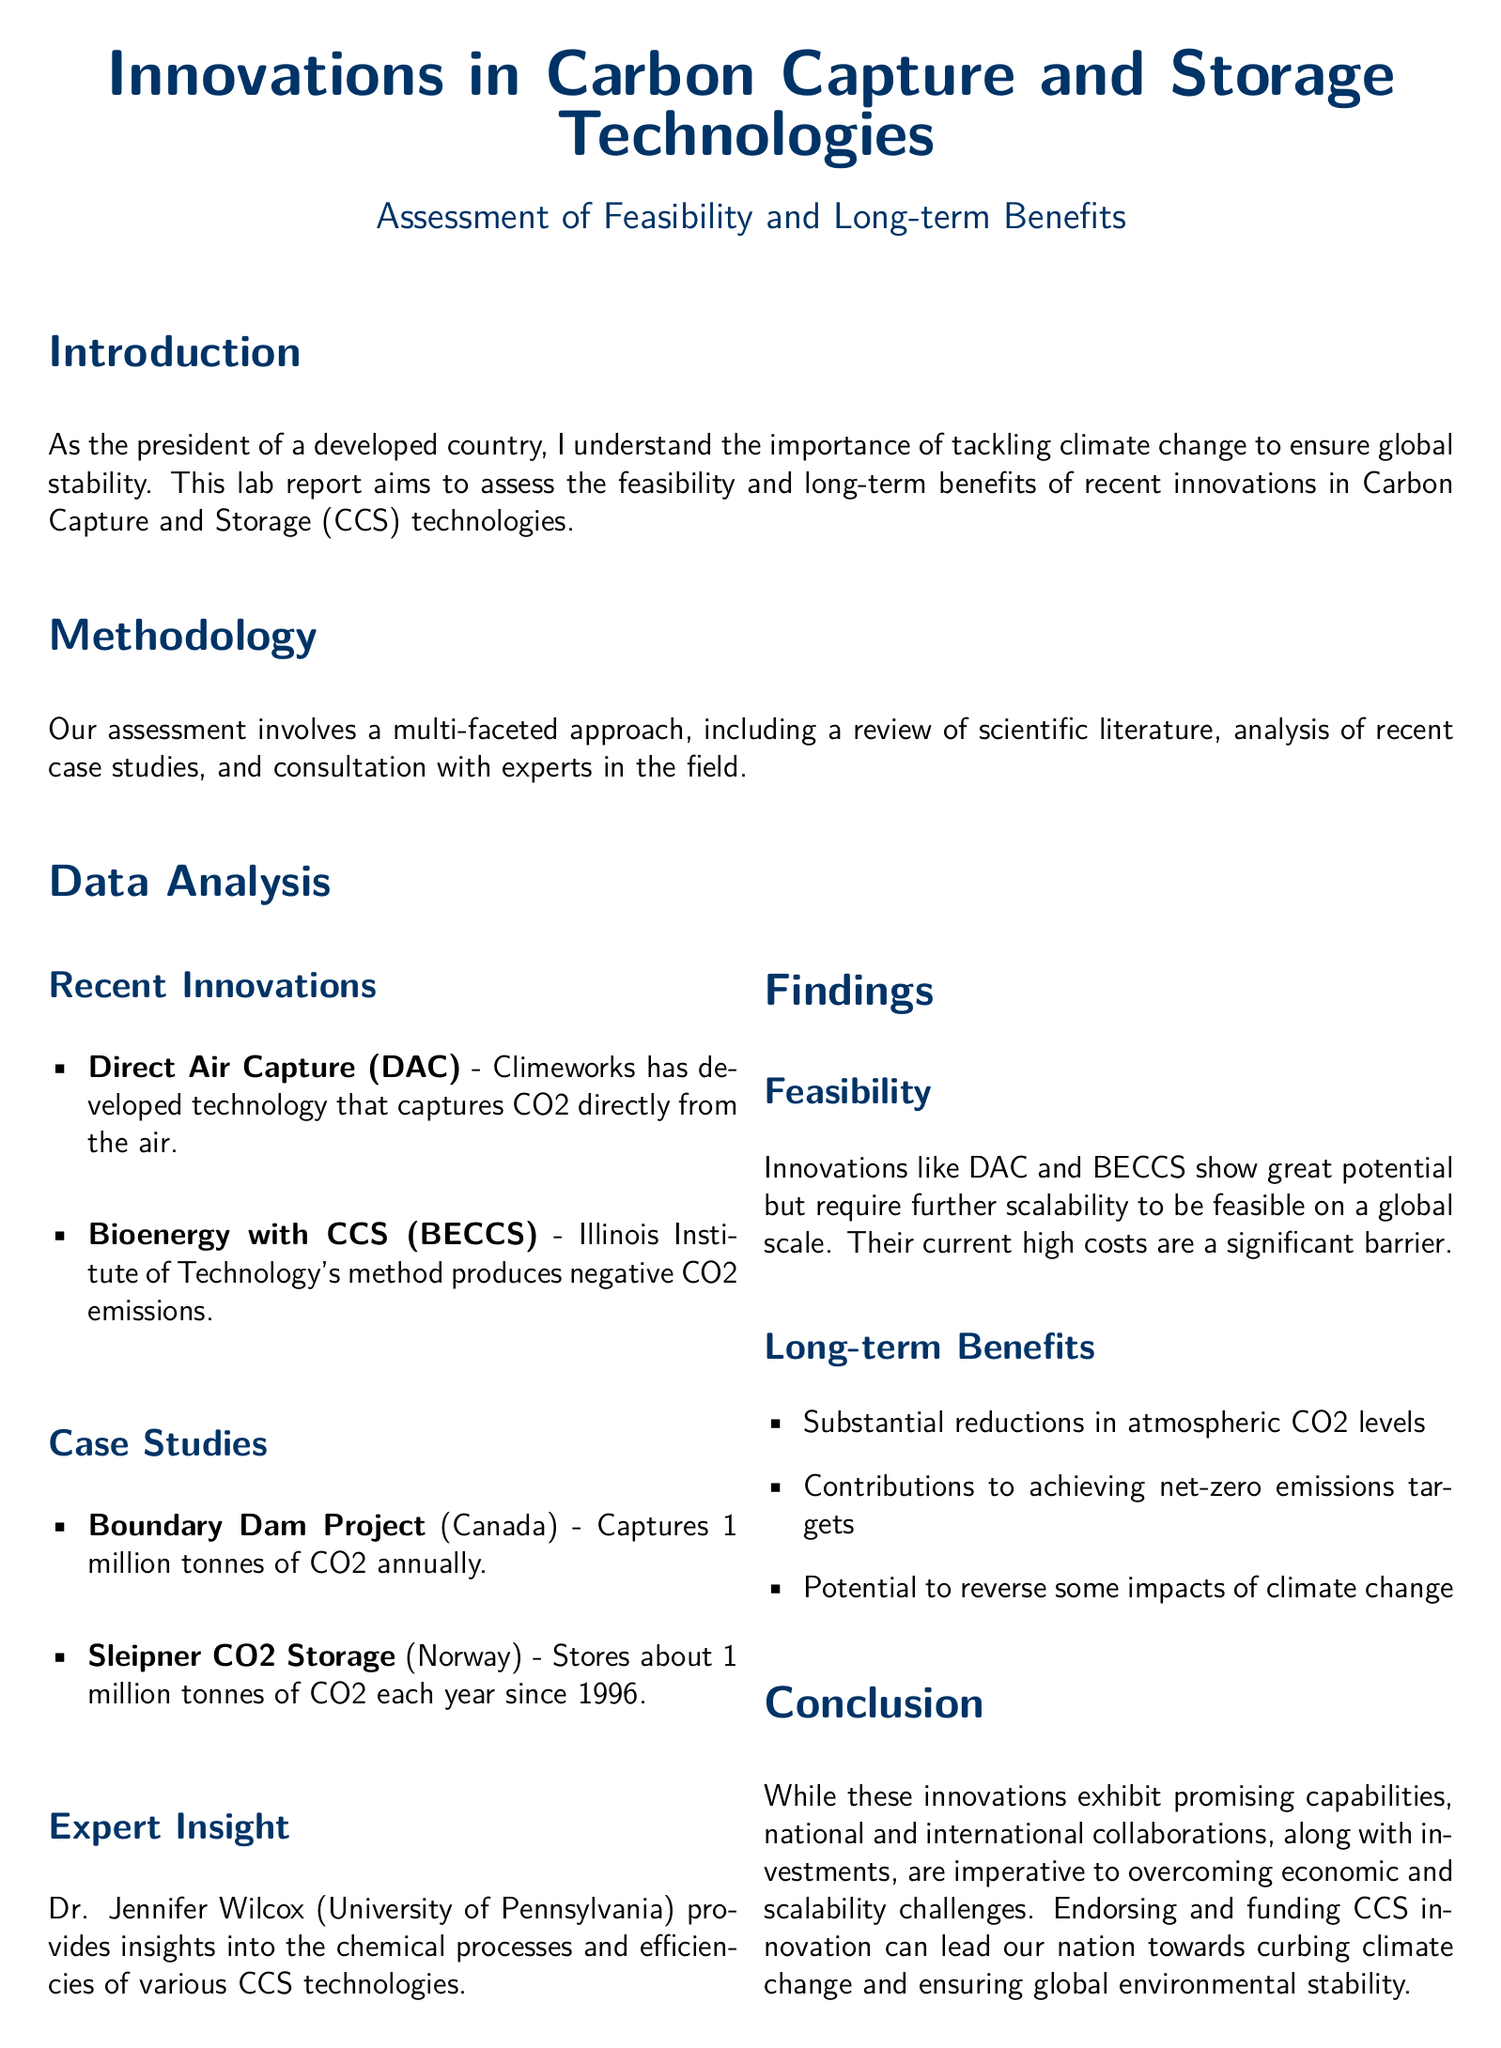what is one recent innovation in carbon capture technology? The document mentions Direct Air Capture (DAC) as a recent innovation in carbon capture technology.
Answer: Direct Air Capture (DAC) how much CO2 does the Boundary Dam Project capture annually? The Boundary Dam Project captures approximately 1 million tonnes of CO2 each year.
Answer: 1 million tonnes who provided expert insight into CCS technologies? The expert insight in the document is provided by Dr. Jennifer Wilcox from the University of Pennsylvania.
Answer: Dr. Jennifer Wilcox what is a significant barrier to the scalability of CCS technologies? The document states that the current high costs are a significant barrier to the scalability of CCS technologies.
Answer: High costs what are two long-term benefits of CCS technologies mentioned in the findings? The document lists substantial reductions in atmospheric CO2 levels and contributions to achieving net-zero emissions targets as benefits.
Answer: Substantial reductions in atmospheric CO2 levels; contributions to achieving net-zero emissions targets what method does the Illinois Institute of Technology develop? The document states that the Illinois Institute of Technology has developed a method called Bioenergy with CCS (BECCS).
Answer: Bioenergy with CCS (BECCS) what is the main purpose of this lab report? The main purpose of the lab report is to assess the feasibility and long-term benefits of recent innovations in Carbon Capture and Storage technologies.
Answer: Assess the feasibility and long-term benefits of recent innovations in Carbon Capture and Storage technologies what type of approach was used for the assessment? The document mentions a multi-faceted approach that includes a review of scientific literature, analysis of case studies, and consultation with experts.
Answer: Multi-faceted approach what is crucial for overcoming challenges in CCS innovation according to the conclusion? The conclusion emphasizes that national and international collaborations, along with investments, are crucial for overcoming challenges in CCS innovation.
Answer: National and international collaborations; investments 